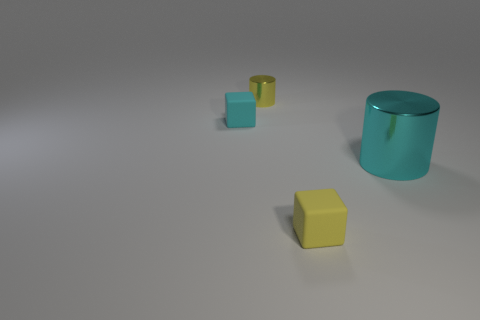Are there more large metal objects in front of the tiny yellow metallic object than large cyan metallic objects that are in front of the large cyan shiny thing?
Your answer should be compact. Yes. Are there any tiny objects that have the same color as the tiny shiny cylinder?
Keep it short and to the point. Yes. Is the cyan metallic object the same size as the yellow rubber cube?
Make the answer very short. No. There is another tiny object that is the same shape as the yellow matte object; what is its material?
Provide a short and direct response. Rubber. The thing that is behind the yellow cube and in front of the cyan cube is made of what material?
Provide a succinct answer. Metal. Is the material of the tiny yellow block the same as the large cylinder?
Provide a succinct answer. No. There is a object that is behind the tiny yellow matte thing and in front of the small cyan cube; what is its size?
Provide a succinct answer. Large. Does the small matte thing that is to the right of the tiny yellow metallic thing have the same color as the tiny cylinder?
Give a very brief answer. Yes. What is the color of the object that is both in front of the tiny yellow cylinder and on the left side of the tiny yellow cube?
Give a very brief answer. Cyan. There is a yellow object to the right of the tiny yellow cylinder; what is it made of?
Provide a succinct answer. Rubber. 